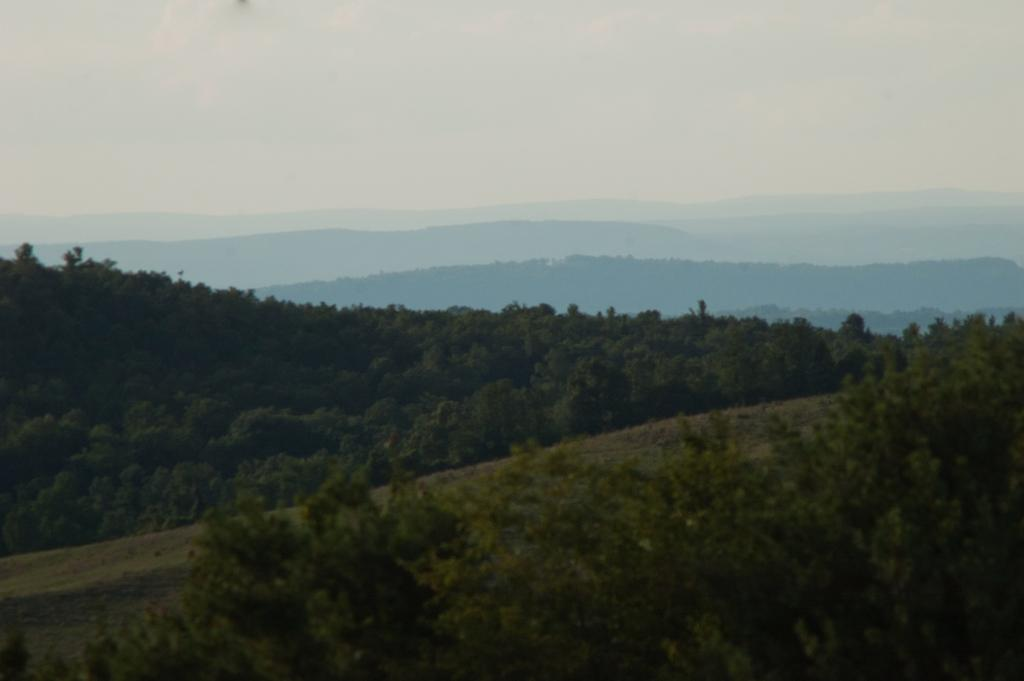What type of vegetation is present on the ground in the image? There are many trees on the ground in the image. What type of geographical feature can be seen in the background of the image? There are mountains visible in the background of the image. What else is visible in the background of the image besides the mountains? The sky is visible in the background of the image. Where is the mailbox located in the image? There is no mailbox present in the image. What color is the tongue of the tree in the image? There are no tongues present in the image, as trees do not have tongues. 